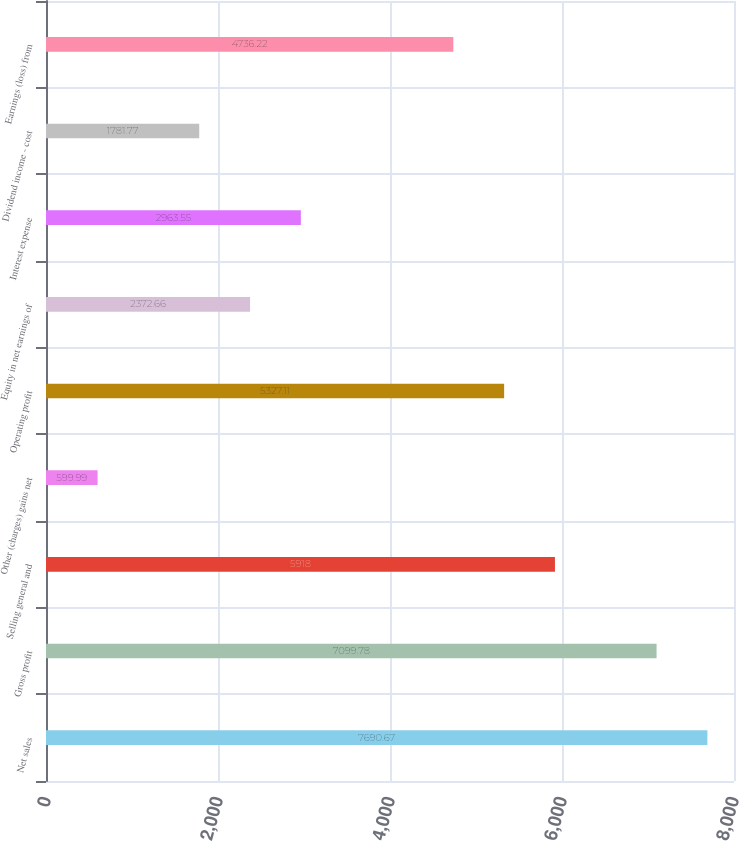Convert chart. <chart><loc_0><loc_0><loc_500><loc_500><bar_chart><fcel>Net sales<fcel>Gross profit<fcel>Selling general and<fcel>Other (charges) gains net<fcel>Operating profit<fcel>Equity in net earnings of<fcel>Interest expense<fcel>Dividend income - cost<fcel>Earnings (loss) from<nl><fcel>7690.67<fcel>7099.78<fcel>5918<fcel>599.99<fcel>5327.11<fcel>2372.66<fcel>2963.55<fcel>1781.77<fcel>4736.22<nl></chart> 